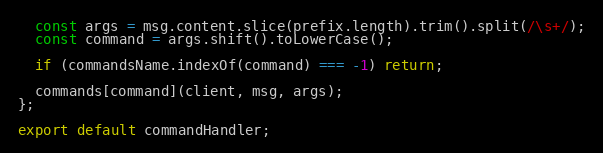<code> <loc_0><loc_0><loc_500><loc_500><_TypeScript_>  const args = msg.content.slice(prefix.length).trim().split(/\s+/);
  const command = args.shift().toLowerCase();

  if (commandsName.indexOf(command) === -1) return;

  commands[command](client, msg, args);
};

export default commandHandler;
</code> 